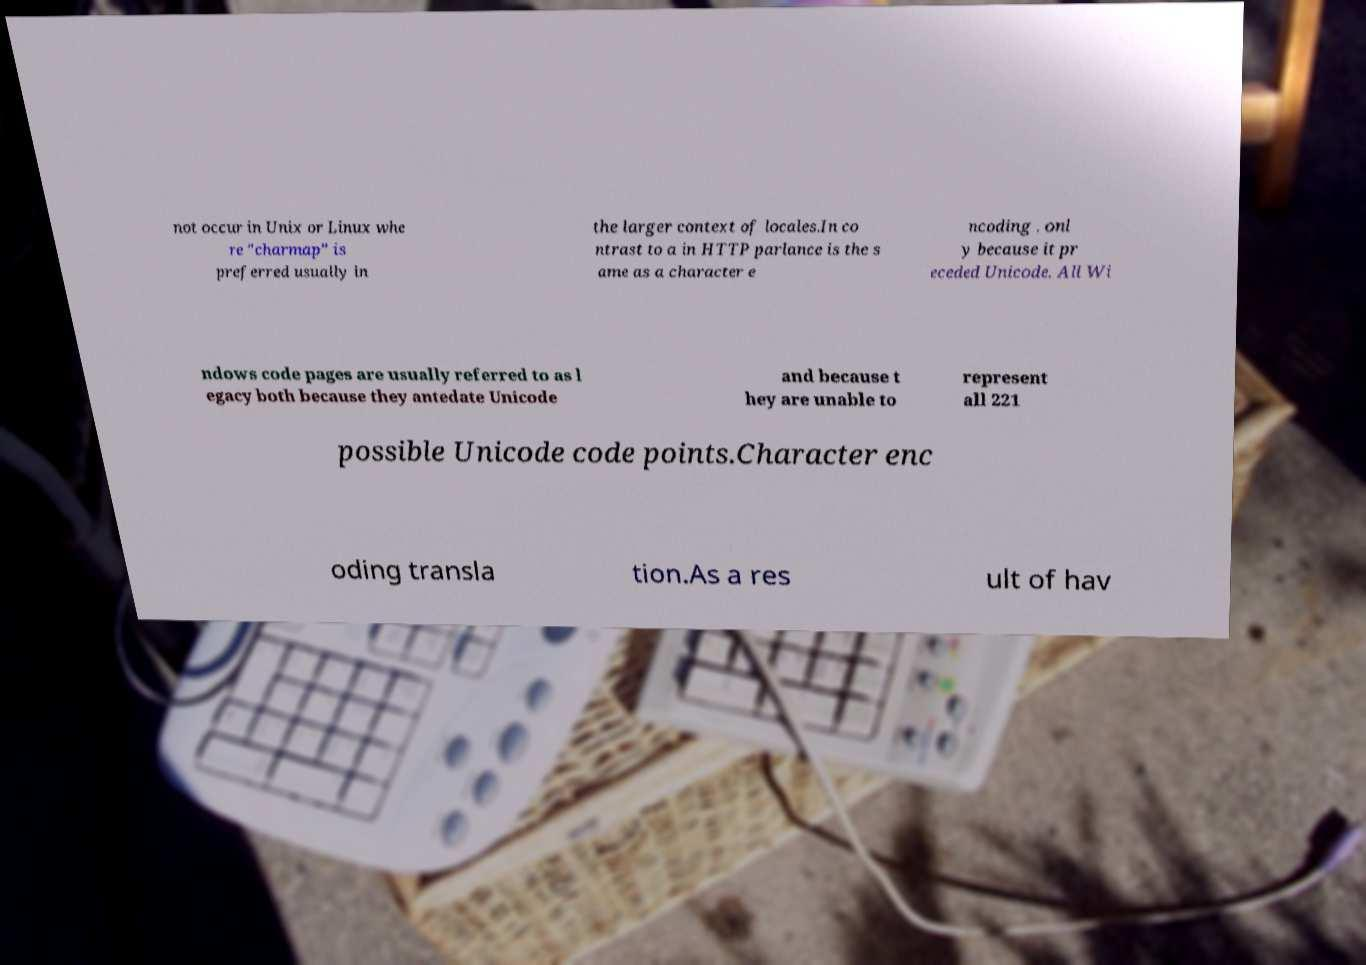Can you read and provide the text displayed in the image?This photo seems to have some interesting text. Can you extract and type it out for me? not occur in Unix or Linux whe re "charmap" is preferred usually in the larger context of locales.In co ntrast to a in HTTP parlance is the s ame as a character e ncoding . onl y because it pr eceded Unicode. All Wi ndows code pages are usually referred to as l egacy both because they antedate Unicode and because t hey are unable to represent all 221 possible Unicode code points.Character enc oding transla tion.As a res ult of hav 